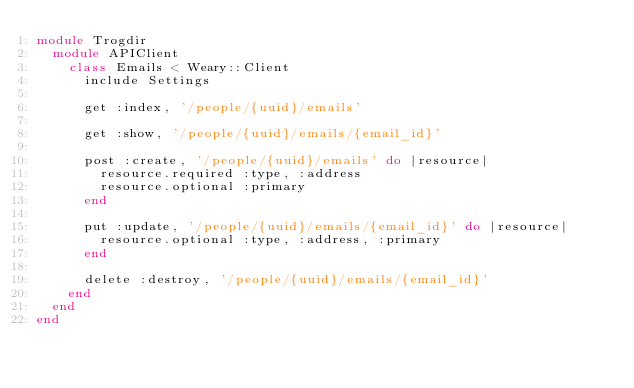Convert code to text. <code><loc_0><loc_0><loc_500><loc_500><_Ruby_>module Trogdir
  module APIClient
    class Emails < Weary::Client
      include Settings

      get :index, '/people/{uuid}/emails'

      get :show, '/people/{uuid}/emails/{email_id}'

      post :create, '/people/{uuid}/emails' do |resource|
        resource.required :type, :address
        resource.optional :primary
      end

      put :update, '/people/{uuid}/emails/{email_id}' do |resource|
        resource.optional :type, :address, :primary
      end

      delete :destroy, '/people/{uuid}/emails/{email_id}'
    end
  end
end
</code> 